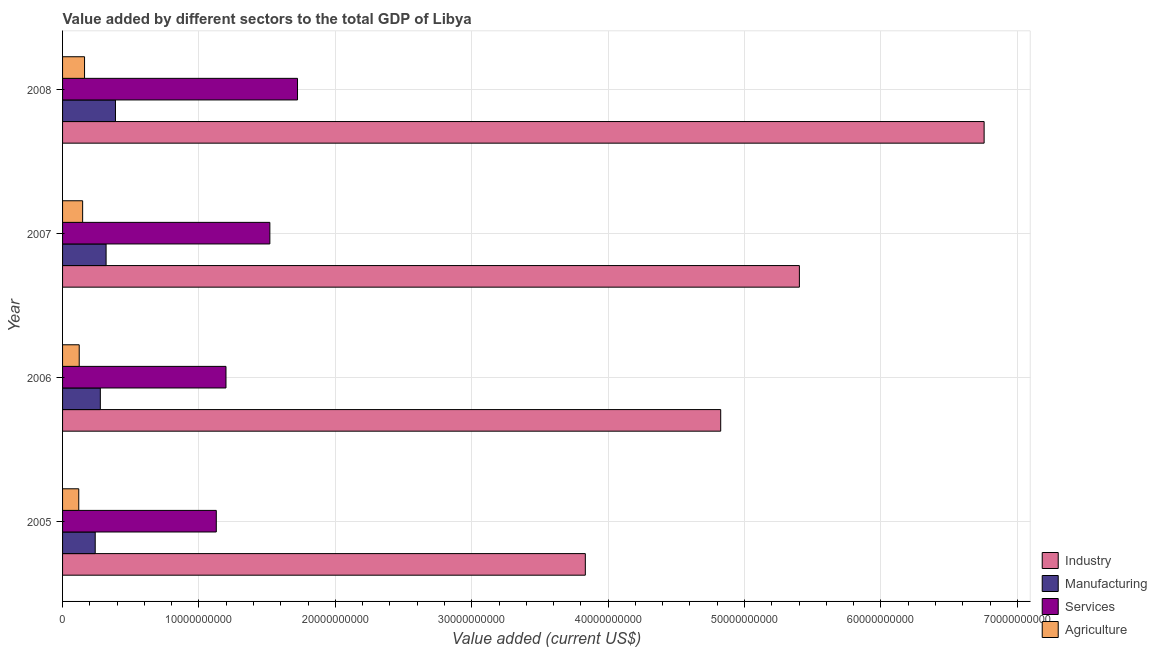How many different coloured bars are there?
Keep it short and to the point. 4. How many groups of bars are there?
Keep it short and to the point. 4. Are the number of bars per tick equal to the number of legend labels?
Provide a succinct answer. Yes. What is the label of the 4th group of bars from the top?
Provide a short and direct response. 2005. In how many cases, is the number of bars for a given year not equal to the number of legend labels?
Ensure brevity in your answer.  0. What is the value added by manufacturing sector in 2005?
Give a very brief answer. 2.39e+09. Across all years, what is the maximum value added by services sector?
Provide a short and direct response. 1.72e+1. Across all years, what is the minimum value added by industrial sector?
Offer a very short reply. 3.83e+1. In which year was the value added by services sector maximum?
Your answer should be compact. 2008. What is the total value added by agricultural sector in the graph?
Your answer should be compact. 5.49e+09. What is the difference between the value added by manufacturing sector in 2005 and that in 2007?
Keep it short and to the point. -7.98e+08. What is the difference between the value added by services sector in 2007 and the value added by agricultural sector in 2005?
Provide a short and direct response. 1.40e+1. What is the average value added by agricultural sector per year?
Your response must be concise. 1.37e+09. In the year 2006, what is the difference between the value added by manufacturing sector and value added by services sector?
Your answer should be very brief. -9.21e+09. What is the ratio of the value added by agricultural sector in 2006 to that in 2007?
Your answer should be compact. 0.83. What is the difference between the highest and the second highest value added by industrial sector?
Provide a short and direct response. 1.35e+1. What is the difference between the highest and the lowest value added by agricultural sector?
Keep it short and to the point. 4.24e+08. In how many years, is the value added by industrial sector greater than the average value added by industrial sector taken over all years?
Provide a succinct answer. 2. Is it the case that in every year, the sum of the value added by services sector and value added by manufacturing sector is greater than the sum of value added by agricultural sector and value added by industrial sector?
Offer a very short reply. No. What does the 1st bar from the top in 2007 represents?
Your response must be concise. Agriculture. What does the 1st bar from the bottom in 2008 represents?
Provide a short and direct response. Industry. Is it the case that in every year, the sum of the value added by industrial sector and value added by manufacturing sector is greater than the value added by services sector?
Your answer should be compact. Yes. How many years are there in the graph?
Provide a short and direct response. 4. What is the difference between two consecutive major ticks on the X-axis?
Make the answer very short. 1.00e+1. Does the graph contain any zero values?
Your answer should be very brief. No. Does the graph contain grids?
Give a very brief answer. Yes. Where does the legend appear in the graph?
Ensure brevity in your answer.  Bottom right. How many legend labels are there?
Provide a succinct answer. 4. What is the title of the graph?
Keep it short and to the point. Value added by different sectors to the total GDP of Libya. Does "Water" appear as one of the legend labels in the graph?
Offer a terse response. No. What is the label or title of the X-axis?
Offer a very short reply. Value added (current US$). What is the label or title of the Y-axis?
Give a very brief answer. Year. What is the Value added (current US$) of Industry in 2005?
Your answer should be compact. 3.83e+1. What is the Value added (current US$) of Manufacturing in 2005?
Provide a short and direct response. 2.39e+09. What is the Value added (current US$) in Services in 2005?
Keep it short and to the point. 1.13e+1. What is the Value added (current US$) of Agriculture in 2005?
Provide a succinct answer. 1.19e+09. What is the Value added (current US$) in Industry in 2006?
Give a very brief answer. 4.83e+1. What is the Value added (current US$) of Manufacturing in 2006?
Keep it short and to the point. 2.77e+09. What is the Value added (current US$) in Services in 2006?
Your response must be concise. 1.20e+1. What is the Value added (current US$) of Agriculture in 2006?
Provide a succinct answer. 1.22e+09. What is the Value added (current US$) in Industry in 2007?
Ensure brevity in your answer.  5.40e+1. What is the Value added (current US$) in Manufacturing in 2007?
Make the answer very short. 3.19e+09. What is the Value added (current US$) in Services in 2007?
Provide a short and direct response. 1.52e+1. What is the Value added (current US$) of Agriculture in 2007?
Keep it short and to the point. 1.47e+09. What is the Value added (current US$) of Industry in 2008?
Your answer should be very brief. 6.76e+1. What is the Value added (current US$) of Manufacturing in 2008?
Your answer should be compact. 3.88e+09. What is the Value added (current US$) in Services in 2008?
Give a very brief answer. 1.72e+1. What is the Value added (current US$) in Agriculture in 2008?
Make the answer very short. 1.61e+09. Across all years, what is the maximum Value added (current US$) in Industry?
Your answer should be compact. 6.76e+1. Across all years, what is the maximum Value added (current US$) of Manufacturing?
Provide a short and direct response. 3.88e+09. Across all years, what is the maximum Value added (current US$) of Services?
Offer a very short reply. 1.72e+1. Across all years, what is the maximum Value added (current US$) in Agriculture?
Offer a terse response. 1.61e+09. Across all years, what is the minimum Value added (current US$) in Industry?
Keep it short and to the point. 3.83e+1. Across all years, what is the minimum Value added (current US$) in Manufacturing?
Keep it short and to the point. 2.39e+09. Across all years, what is the minimum Value added (current US$) in Services?
Provide a short and direct response. 1.13e+1. Across all years, what is the minimum Value added (current US$) in Agriculture?
Make the answer very short. 1.19e+09. What is the total Value added (current US$) in Industry in the graph?
Offer a terse response. 2.08e+11. What is the total Value added (current US$) of Manufacturing in the graph?
Your answer should be very brief. 1.22e+1. What is the total Value added (current US$) in Services in the graph?
Your answer should be very brief. 5.57e+1. What is the total Value added (current US$) of Agriculture in the graph?
Your answer should be very brief. 5.49e+09. What is the difference between the Value added (current US$) in Industry in 2005 and that in 2006?
Ensure brevity in your answer.  -9.93e+09. What is the difference between the Value added (current US$) in Manufacturing in 2005 and that in 2006?
Make the answer very short. -3.75e+08. What is the difference between the Value added (current US$) in Services in 2005 and that in 2006?
Offer a very short reply. -7.10e+08. What is the difference between the Value added (current US$) in Agriculture in 2005 and that in 2006?
Give a very brief answer. -3.24e+07. What is the difference between the Value added (current US$) of Industry in 2005 and that in 2007?
Ensure brevity in your answer.  -1.57e+1. What is the difference between the Value added (current US$) in Manufacturing in 2005 and that in 2007?
Provide a succinct answer. -7.98e+08. What is the difference between the Value added (current US$) in Services in 2005 and that in 2007?
Provide a succinct answer. -3.93e+09. What is the difference between the Value added (current US$) of Agriculture in 2005 and that in 2007?
Offer a terse response. -2.84e+08. What is the difference between the Value added (current US$) in Industry in 2005 and that in 2008?
Ensure brevity in your answer.  -2.92e+1. What is the difference between the Value added (current US$) of Manufacturing in 2005 and that in 2008?
Keep it short and to the point. -1.49e+09. What is the difference between the Value added (current US$) of Services in 2005 and that in 2008?
Make the answer very short. -5.96e+09. What is the difference between the Value added (current US$) in Agriculture in 2005 and that in 2008?
Offer a very short reply. -4.24e+08. What is the difference between the Value added (current US$) in Industry in 2006 and that in 2007?
Your answer should be compact. -5.77e+09. What is the difference between the Value added (current US$) in Manufacturing in 2006 and that in 2007?
Give a very brief answer. -4.23e+08. What is the difference between the Value added (current US$) of Services in 2006 and that in 2007?
Ensure brevity in your answer.  -3.22e+09. What is the difference between the Value added (current US$) of Agriculture in 2006 and that in 2007?
Make the answer very short. -2.52e+08. What is the difference between the Value added (current US$) in Industry in 2006 and that in 2008?
Your answer should be very brief. -1.93e+1. What is the difference between the Value added (current US$) of Manufacturing in 2006 and that in 2008?
Offer a terse response. -1.11e+09. What is the difference between the Value added (current US$) in Services in 2006 and that in 2008?
Offer a terse response. -5.25e+09. What is the difference between the Value added (current US$) in Agriculture in 2006 and that in 2008?
Make the answer very short. -3.91e+08. What is the difference between the Value added (current US$) of Industry in 2007 and that in 2008?
Give a very brief answer. -1.35e+1. What is the difference between the Value added (current US$) of Manufacturing in 2007 and that in 2008?
Ensure brevity in your answer.  -6.87e+08. What is the difference between the Value added (current US$) in Services in 2007 and that in 2008?
Provide a succinct answer. -2.03e+09. What is the difference between the Value added (current US$) in Agriculture in 2007 and that in 2008?
Provide a succinct answer. -1.39e+08. What is the difference between the Value added (current US$) of Industry in 2005 and the Value added (current US$) of Manufacturing in 2006?
Ensure brevity in your answer.  3.56e+1. What is the difference between the Value added (current US$) of Industry in 2005 and the Value added (current US$) of Services in 2006?
Make the answer very short. 2.63e+1. What is the difference between the Value added (current US$) in Industry in 2005 and the Value added (current US$) in Agriculture in 2006?
Offer a terse response. 3.71e+1. What is the difference between the Value added (current US$) of Manufacturing in 2005 and the Value added (current US$) of Services in 2006?
Ensure brevity in your answer.  -9.59e+09. What is the difference between the Value added (current US$) of Manufacturing in 2005 and the Value added (current US$) of Agriculture in 2006?
Offer a very short reply. 1.17e+09. What is the difference between the Value added (current US$) in Services in 2005 and the Value added (current US$) in Agriculture in 2006?
Keep it short and to the point. 1.01e+1. What is the difference between the Value added (current US$) of Industry in 2005 and the Value added (current US$) of Manufacturing in 2007?
Offer a terse response. 3.51e+1. What is the difference between the Value added (current US$) of Industry in 2005 and the Value added (current US$) of Services in 2007?
Provide a short and direct response. 2.31e+1. What is the difference between the Value added (current US$) in Industry in 2005 and the Value added (current US$) in Agriculture in 2007?
Provide a short and direct response. 3.69e+1. What is the difference between the Value added (current US$) in Manufacturing in 2005 and the Value added (current US$) in Services in 2007?
Make the answer very short. -1.28e+1. What is the difference between the Value added (current US$) of Manufacturing in 2005 and the Value added (current US$) of Agriculture in 2007?
Ensure brevity in your answer.  9.21e+08. What is the difference between the Value added (current US$) of Services in 2005 and the Value added (current US$) of Agriculture in 2007?
Offer a very short reply. 9.80e+09. What is the difference between the Value added (current US$) in Industry in 2005 and the Value added (current US$) in Manufacturing in 2008?
Provide a succinct answer. 3.44e+1. What is the difference between the Value added (current US$) of Industry in 2005 and the Value added (current US$) of Services in 2008?
Offer a very short reply. 2.11e+1. What is the difference between the Value added (current US$) in Industry in 2005 and the Value added (current US$) in Agriculture in 2008?
Provide a short and direct response. 3.67e+1. What is the difference between the Value added (current US$) of Manufacturing in 2005 and the Value added (current US$) of Services in 2008?
Your answer should be compact. -1.48e+1. What is the difference between the Value added (current US$) in Manufacturing in 2005 and the Value added (current US$) in Agriculture in 2008?
Your answer should be compact. 7.82e+08. What is the difference between the Value added (current US$) of Services in 2005 and the Value added (current US$) of Agriculture in 2008?
Your answer should be very brief. 9.66e+09. What is the difference between the Value added (current US$) of Industry in 2006 and the Value added (current US$) of Manufacturing in 2007?
Give a very brief answer. 4.51e+1. What is the difference between the Value added (current US$) in Industry in 2006 and the Value added (current US$) in Services in 2007?
Your answer should be compact. 3.31e+1. What is the difference between the Value added (current US$) of Industry in 2006 and the Value added (current US$) of Agriculture in 2007?
Give a very brief answer. 4.68e+1. What is the difference between the Value added (current US$) of Manufacturing in 2006 and the Value added (current US$) of Services in 2007?
Offer a very short reply. -1.24e+1. What is the difference between the Value added (current US$) in Manufacturing in 2006 and the Value added (current US$) in Agriculture in 2007?
Offer a very short reply. 1.30e+09. What is the difference between the Value added (current US$) in Services in 2006 and the Value added (current US$) in Agriculture in 2007?
Your answer should be very brief. 1.05e+1. What is the difference between the Value added (current US$) of Industry in 2006 and the Value added (current US$) of Manufacturing in 2008?
Provide a short and direct response. 4.44e+1. What is the difference between the Value added (current US$) of Industry in 2006 and the Value added (current US$) of Services in 2008?
Your answer should be very brief. 3.10e+1. What is the difference between the Value added (current US$) in Industry in 2006 and the Value added (current US$) in Agriculture in 2008?
Offer a terse response. 4.66e+1. What is the difference between the Value added (current US$) of Manufacturing in 2006 and the Value added (current US$) of Services in 2008?
Make the answer very short. -1.45e+1. What is the difference between the Value added (current US$) in Manufacturing in 2006 and the Value added (current US$) in Agriculture in 2008?
Offer a terse response. 1.16e+09. What is the difference between the Value added (current US$) in Services in 2006 and the Value added (current US$) in Agriculture in 2008?
Provide a short and direct response. 1.04e+1. What is the difference between the Value added (current US$) of Industry in 2007 and the Value added (current US$) of Manufacturing in 2008?
Keep it short and to the point. 5.01e+1. What is the difference between the Value added (current US$) of Industry in 2007 and the Value added (current US$) of Services in 2008?
Your response must be concise. 3.68e+1. What is the difference between the Value added (current US$) in Industry in 2007 and the Value added (current US$) in Agriculture in 2008?
Make the answer very short. 5.24e+1. What is the difference between the Value added (current US$) in Manufacturing in 2007 and the Value added (current US$) in Services in 2008?
Offer a terse response. -1.40e+1. What is the difference between the Value added (current US$) of Manufacturing in 2007 and the Value added (current US$) of Agriculture in 2008?
Ensure brevity in your answer.  1.58e+09. What is the difference between the Value added (current US$) of Services in 2007 and the Value added (current US$) of Agriculture in 2008?
Ensure brevity in your answer.  1.36e+1. What is the average Value added (current US$) of Industry per year?
Your answer should be very brief. 5.20e+1. What is the average Value added (current US$) in Manufacturing per year?
Provide a short and direct response. 3.06e+09. What is the average Value added (current US$) in Services per year?
Your answer should be very brief. 1.39e+1. What is the average Value added (current US$) in Agriculture per year?
Your answer should be compact. 1.37e+09. In the year 2005, what is the difference between the Value added (current US$) in Industry and Value added (current US$) in Manufacturing?
Your response must be concise. 3.59e+1. In the year 2005, what is the difference between the Value added (current US$) of Industry and Value added (current US$) of Services?
Make the answer very short. 2.71e+1. In the year 2005, what is the difference between the Value added (current US$) of Industry and Value added (current US$) of Agriculture?
Provide a short and direct response. 3.71e+1. In the year 2005, what is the difference between the Value added (current US$) of Manufacturing and Value added (current US$) of Services?
Your answer should be compact. -8.88e+09. In the year 2005, what is the difference between the Value added (current US$) in Manufacturing and Value added (current US$) in Agriculture?
Keep it short and to the point. 1.21e+09. In the year 2005, what is the difference between the Value added (current US$) of Services and Value added (current US$) of Agriculture?
Offer a very short reply. 1.01e+1. In the year 2006, what is the difference between the Value added (current US$) of Industry and Value added (current US$) of Manufacturing?
Provide a short and direct response. 4.55e+1. In the year 2006, what is the difference between the Value added (current US$) of Industry and Value added (current US$) of Services?
Ensure brevity in your answer.  3.63e+1. In the year 2006, what is the difference between the Value added (current US$) of Industry and Value added (current US$) of Agriculture?
Offer a very short reply. 4.70e+1. In the year 2006, what is the difference between the Value added (current US$) in Manufacturing and Value added (current US$) in Services?
Your answer should be very brief. -9.21e+09. In the year 2006, what is the difference between the Value added (current US$) of Manufacturing and Value added (current US$) of Agriculture?
Ensure brevity in your answer.  1.55e+09. In the year 2006, what is the difference between the Value added (current US$) of Services and Value added (current US$) of Agriculture?
Ensure brevity in your answer.  1.08e+1. In the year 2007, what is the difference between the Value added (current US$) of Industry and Value added (current US$) of Manufacturing?
Your answer should be very brief. 5.08e+1. In the year 2007, what is the difference between the Value added (current US$) of Industry and Value added (current US$) of Services?
Offer a terse response. 3.88e+1. In the year 2007, what is the difference between the Value added (current US$) of Industry and Value added (current US$) of Agriculture?
Give a very brief answer. 5.26e+1. In the year 2007, what is the difference between the Value added (current US$) in Manufacturing and Value added (current US$) in Services?
Provide a succinct answer. -1.20e+1. In the year 2007, what is the difference between the Value added (current US$) in Manufacturing and Value added (current US$) in Agriculture?
Ensure brevity in your answer.  1.72e+09. In the year 2007, what is the difference between the Value added (current US$) in Services and Value added (current US$) in Agriculture?
Your answer should be compact. 1.37e+1. In the year 2008, what is the difference between the Value added (current US$) of Industry and Value added (current US$) of Manufacturing?
Provide a succinct answer. 6.37e+1. In the year 2008, what is the difference between the Value added (current US$) in Industry and Value added (current US$) in Services?
Offer a terse response. 5.03e+1. In the year 2008, what is the difference between the Value added (current US$) of Industry and Value added (current US$) of Agriculture?
Offer a very short reply. 6.60e+1. In the year 2008, what is the difference between the Value added (current US$) in Manufacturing and Value added (current US$) in Services?
Offer a terse response. -1.33e+1. In the year 2008, what is the difference between the Value added (current US$) in Manufacturing and Value added (current US$) in Agriculture?
Ensure brevity in your answer.  2.27e+09. In the year 2008, what is the difference between the Value added (current US$) of Services and Value added (current US$) of Agriculture?
Keep it short and to the point. 1.56e+1. What is the ratio of the Value added (current US$) in Industry in 2005 to that in 2006?
Your answer should be compact. 0.79. What is the ratio of the Value added (current US$) of Manufacturing in 2005 to that in 2006?
Make the answer very short. 0.86. What is the ratio of the Value added (current US$) of Services in 2005 to that in 2006?
Offer a terse response. 0.94. What is the ratio of the Value added (current US$) in Agriculture in 2005 to that in 2006?
Ensure brevity in your answer.  0.97. What is the ratio of the Value added (current US$) in Industry in 2005 to that in 2007?
Your answer should be very brief. 0.71. What is the ratio of the Value added (current US$) in Manufacturing in 2005 to that in 2007?
Offer a terse response. 0.75. What is the ratio of the Value added (current US$) of Services in 2005 to that in 2007?
Offer a terse response. 0.74. What is the ratio of the Value added (current US$) in Agriculture in 2005 to that in 2007?
Your answer should be very brief. 0.81. What is the ratio of the Value added (current US$) of Industry in 2005 to that in 2008?
Your response must be concise. 0.57. What is the ratio of the Value added (current US$) of Manufacturing in 2005 to that in 2008?
Your answer should be very brief. 0.62. What is the ratio of the Value added (current US$) of Services in 2005 to that in 2008?
Ensure brevity in your answer.  0.65. What is the ratio of the Value added (current US$) in Agriculture in 2005 to that in 2008?
Offer a terse response. 0.74. What is the ratio of the Value added (current US$) in Industry in 2006 to that in 2007?
Provide a short and direct response. 0.89. What is the ratio of the Value added (current US$) of Manufacturing in 2006 to that in 2007?
Provide a short and direct response. 0.87. What is the ratio of the Value added (current US$) in Services in 2006 to that in 2007?
Make the answer very short. 0.79. What is the ratio of the Value added (current US$) in Agriculture in 2006 to that in 2007?
Your answer should be very brief. 0.83. What is the ratio of the Value added (current US$) of Industry in 2006 to that in 2008?
Give a very brief answer. 0.71. What is the ratio of the Value added (current US$) in Manufacturing in 2006 to that in 2008?
Offer a very short reply. 0.71. What is the ratio of the Value added (current US$) of Services in 2006 to that in 2008?
Your answer should be very brief. 0.7. What is the ratio of the Value added (current US$) of Agriculture in 2006 to that in 2008?
Your answer should be compact. 0.76. What is the ratio of the Value added (current US$) of Industry in 2007 to that in 2008?
Your answer should be compact. 0.8. What is the ratio of the Value added (current US$) in Manufacturing in 2007 to that in 2008?
Keep it short and to the point. 0.82. What is the ratio of the Value added (current US$) in Services in 2007 to that in 2008?
Offer a very short reply. 0.88. What is the ratio of the Value added (current US$) of Agriculture in 2007 to that in 2008?
Your answer should be compact. 0.91. What is the difference between the highest and the second highest Value added (current US$) in Industry?
Your response must be concise. 1.35e+1. What is the difference between the highest and the second highest Value added (current US$) in Manufacturing?
Offer a terse response. 6.87e+08. What is the difference between the highest and the second highest Value added (current US$) of Services?
Give a very brief answer. 2.03e+09. What is the difference between the highest and the second highest Value added (current US$) of Agriculture?
Provide a short and direct response. 1.39e+08. What is the difference between the highest and the lowest Value added (current US$) in Industry?
Make the answer very short. 2.92e+1. What is the difference between the highest and the lowest Value added (current US$) of Manufacturing?
Give a very brief answer. 1.49e+09. What is the difference between the highest and the lowest Value added (current US$) in Services?
Your response must be concise. 5.96e+09. What is the difference between the highest and the lowest Value added (current US$) of Agriculture?
Provide a short and direct response. 4.24e+08. 